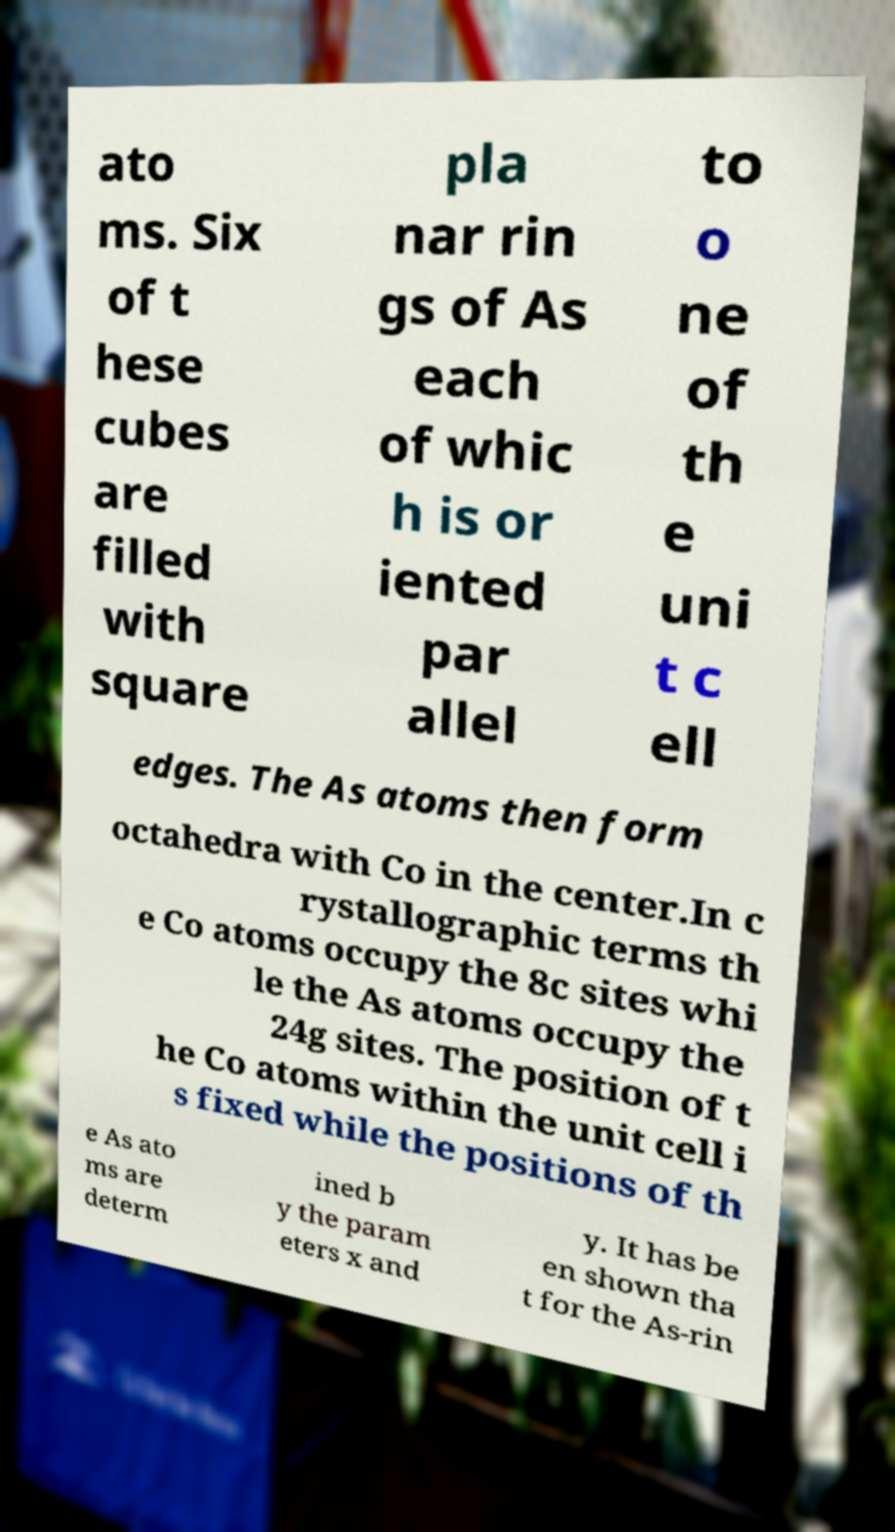I need the written content from this picture converted into text. Can you do that? ato ms. Six of t hese cubes are filled with square pla nar rin gs of As each of whic h is or iented par allel to o ne of th e uni t c ell edges. The As atoms then form octahedra with Co in the center.In c rystallographic terms th e Co atoms occupy the 8c sites whi le the As atoms occupy the 24g sites. The position of t he Co atoms within the unit cell i s fixed while the positions of th e As ato ms are determ ined b y the param eters x and y. It has be en shown tha t for the As-rin 